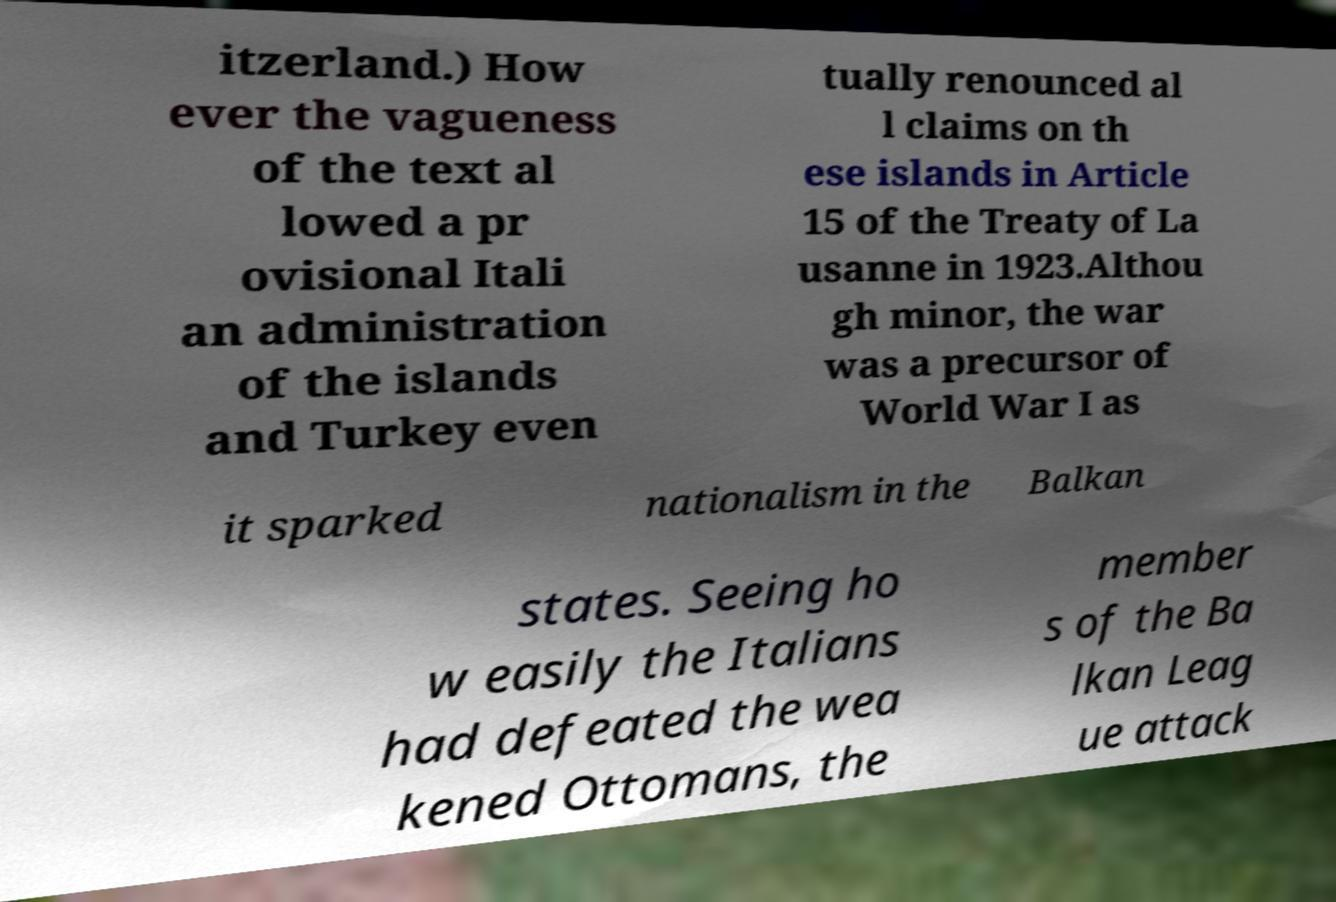What messages or text are displayed in this image? I need them in a readable, typed format. itzerland.) How ever the vagueness of the text al lowed a pr ovisional Itali an administration of the islands and Turkey even tually renounced al l claims on th ese islands in Article 15 of the Treaty of La usanne in 1923.Althou gh minor, the war was a precursor of World War I as it sparked nationalism in the Balkan states. Seeing ho w easily the Italians had defeated the wea kened Ottomans, the member s of the Ba lkan Leag ue attack 